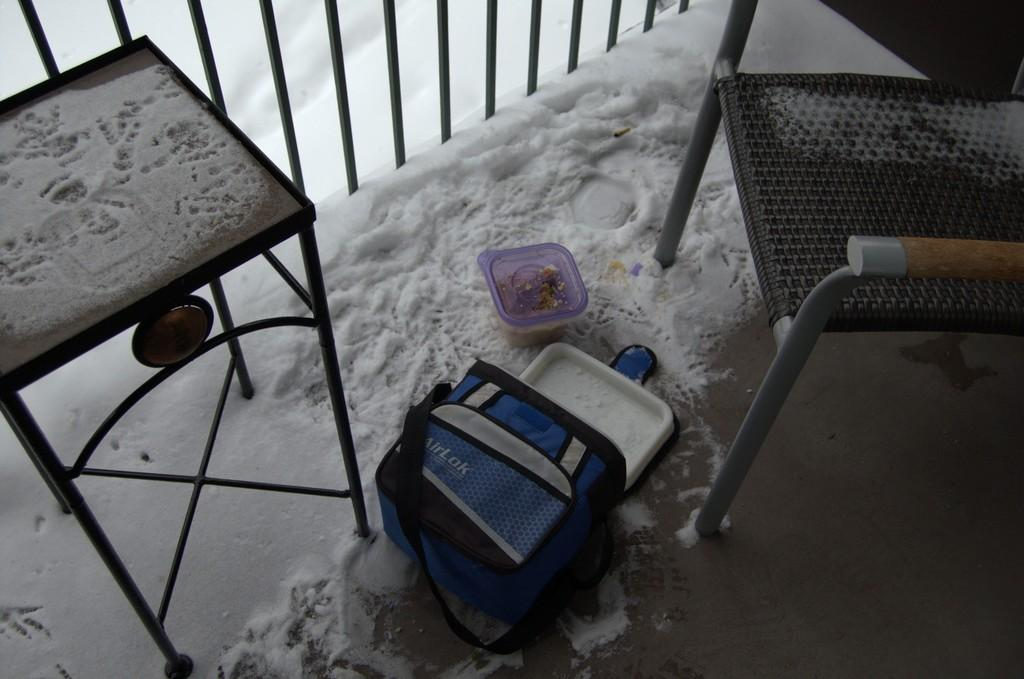What is located in the middle of the image? There is a box and a container in the middle of the image. What type of objects are the box and container? The specific type of box and container is not mentioned, but they are both objects in the image. What type of seating is visible in the image? There are chairs in the image. What can be seen in the background behind the container? There is snow and fencing visible in the background behind the container. Who is the creator of the snow visible in the image? The creator of the snow is not mentioned in the image, as snow is a natural occurrence and not created by a specific individual. 